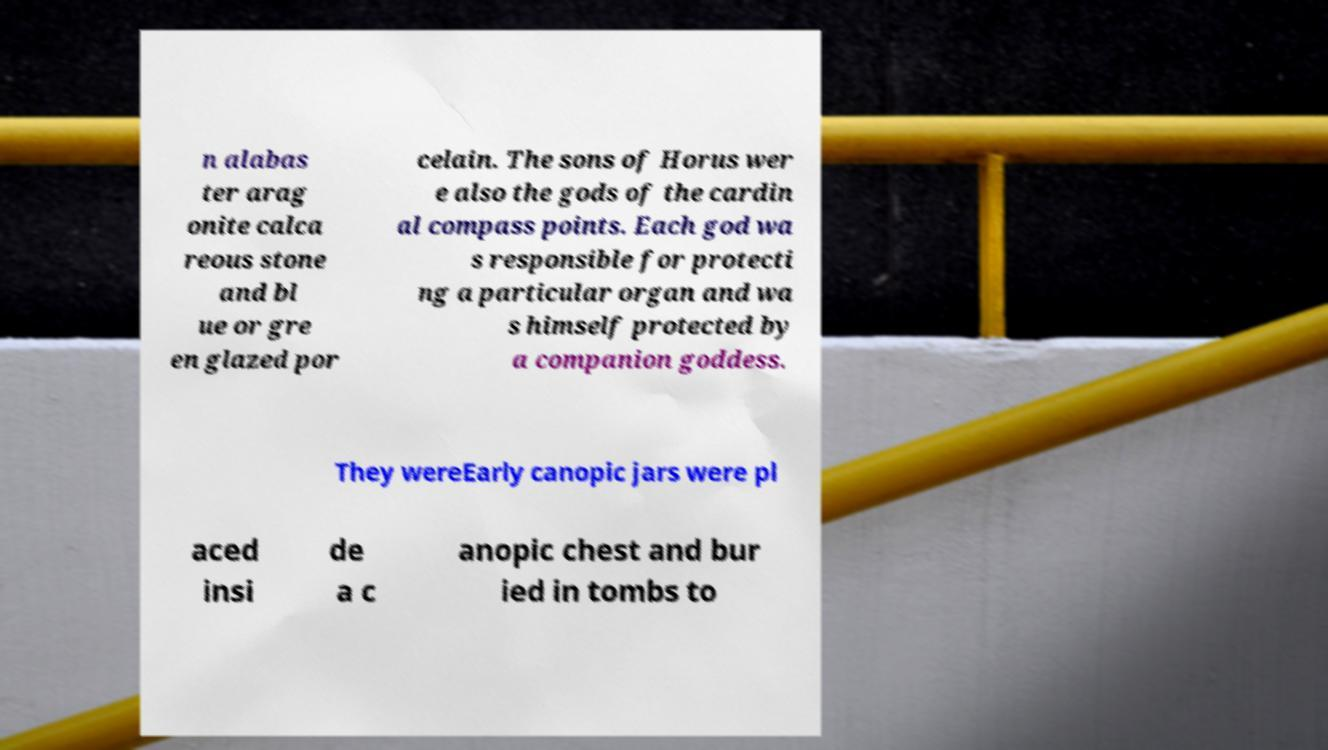What messages or text are displayed in this image? I need them in a readable, typed format. n alabas ter arag onite calca reous stone and bl ue or gre en glazed por celain. The sons of Horus wer e also the gods of the cardin al compass points. Each god wa s responsible for protecti ng a particular organ and wa s himself protected by a companion goddess. They wereEarly canopic jars were pl aced insi de a c anopic chest and bur ied in tombs to 